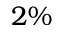Convert formula to latex. <formula><loc_0><loc_0><loc_500><loc_500>2 \%</formula> 